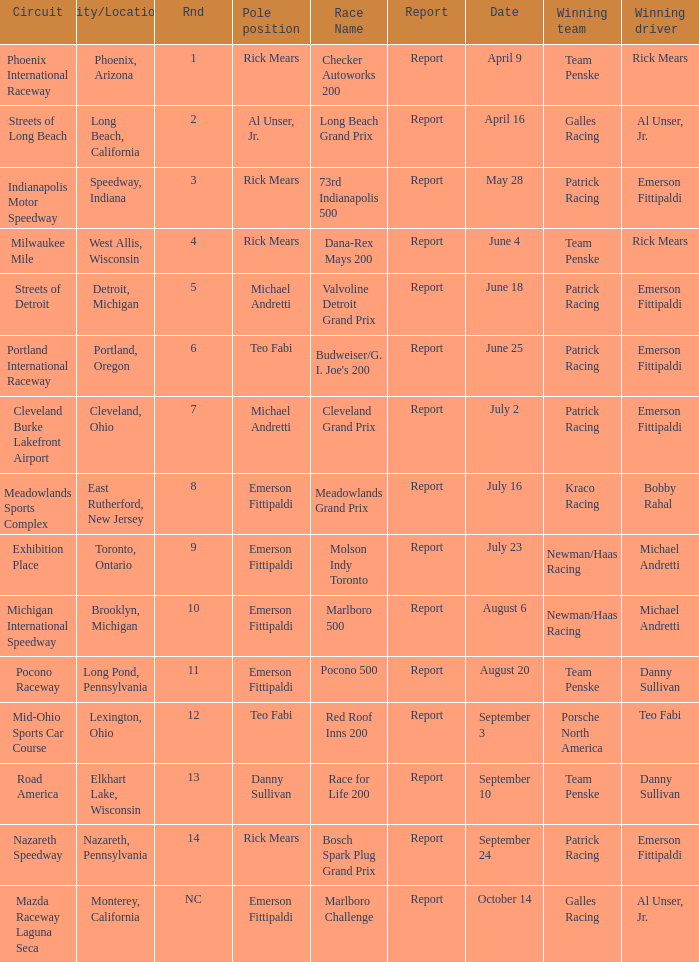Who was the pole position for the rnd equalling 12? Teo Fabi. 